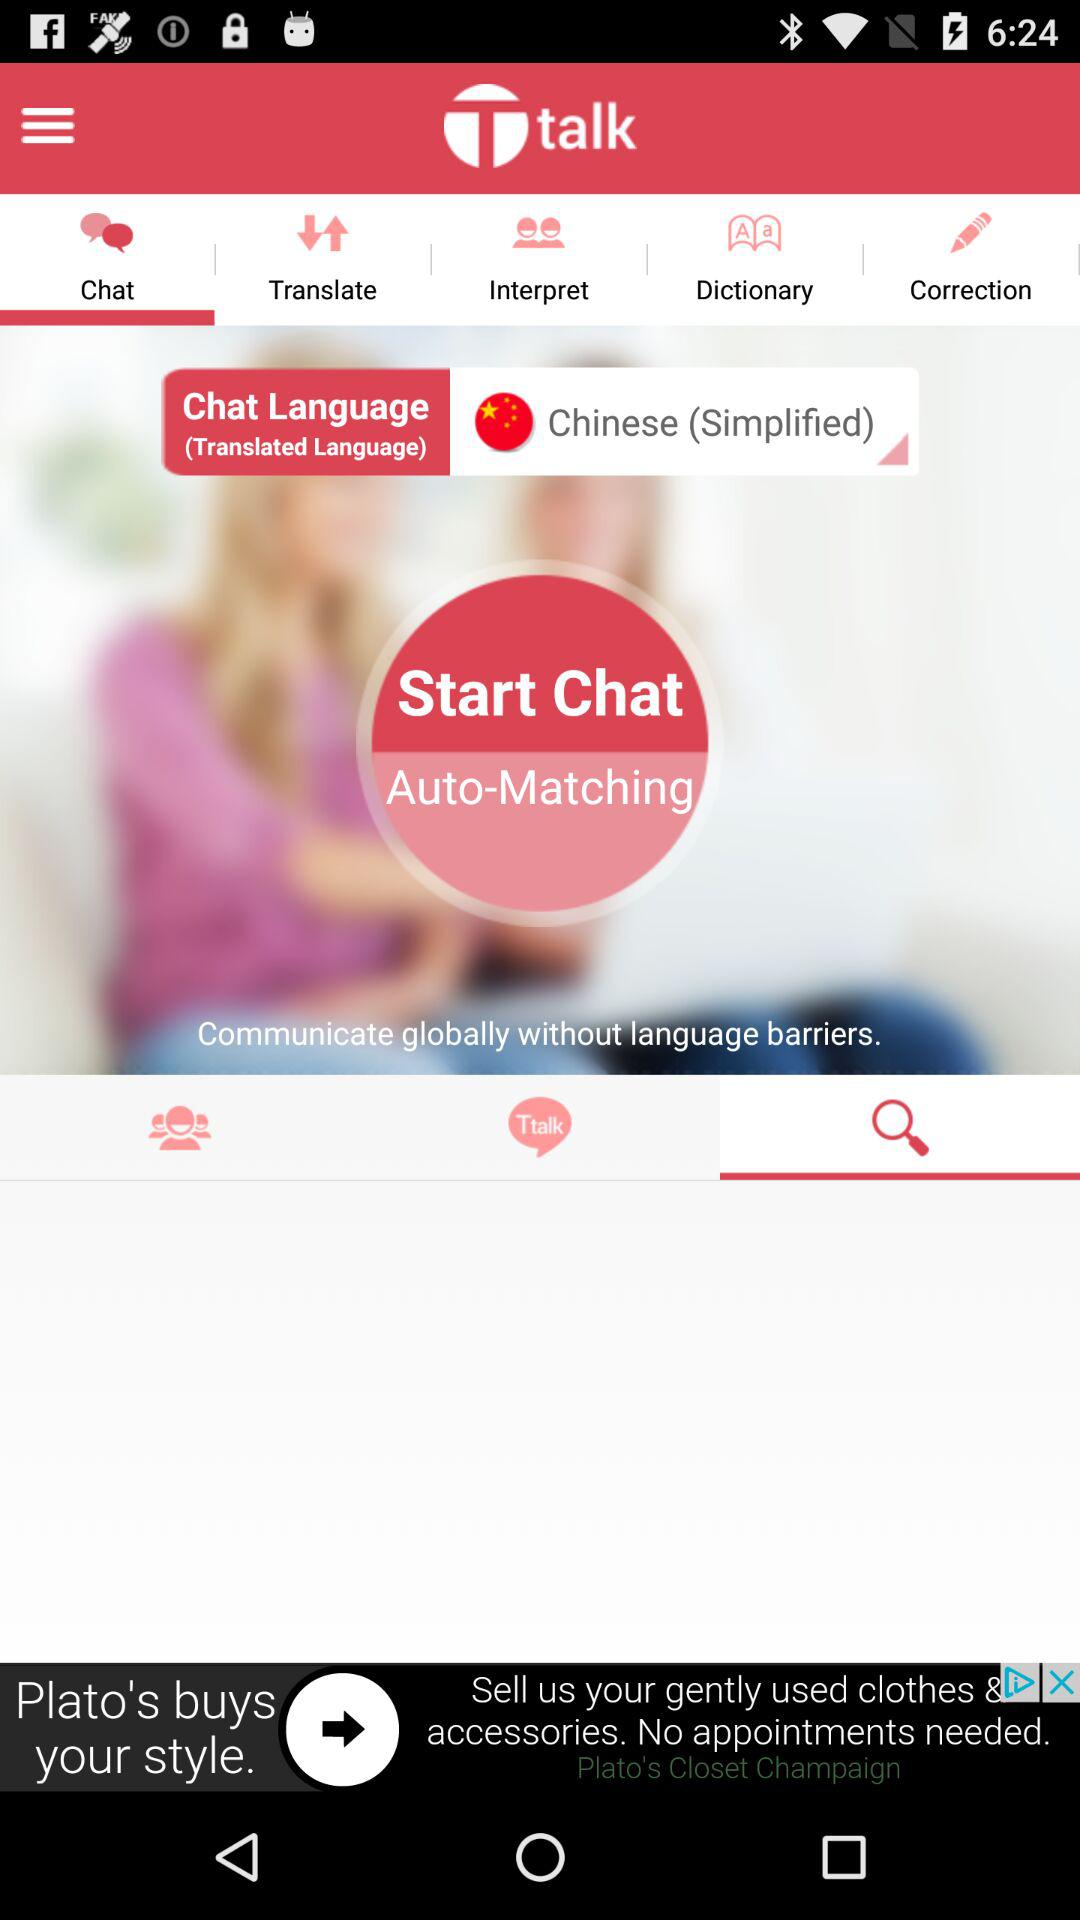Which language is used to chat? The used language is Chinese (simplified). 